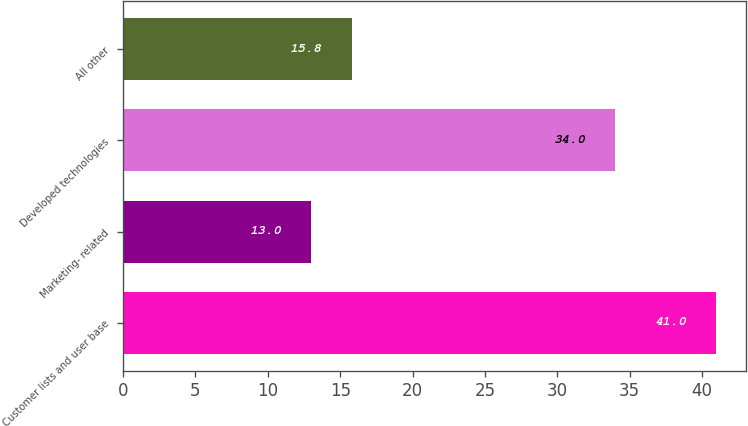Convert chart. <chart><loc_0><loc_0><loc_500><loc_500><bar_chart><fcel>Customer lists and user base<fcel>Marketing- related<fcel>Developed technologies<fcel>All other<nl><fcel>41<fcel>13<fcel>34<fcel>15.8<nl></chart> 